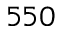Convert formula to latex. <formula><loc_0><loc_0><loc_500><loc_500>5 5 0</formula> 